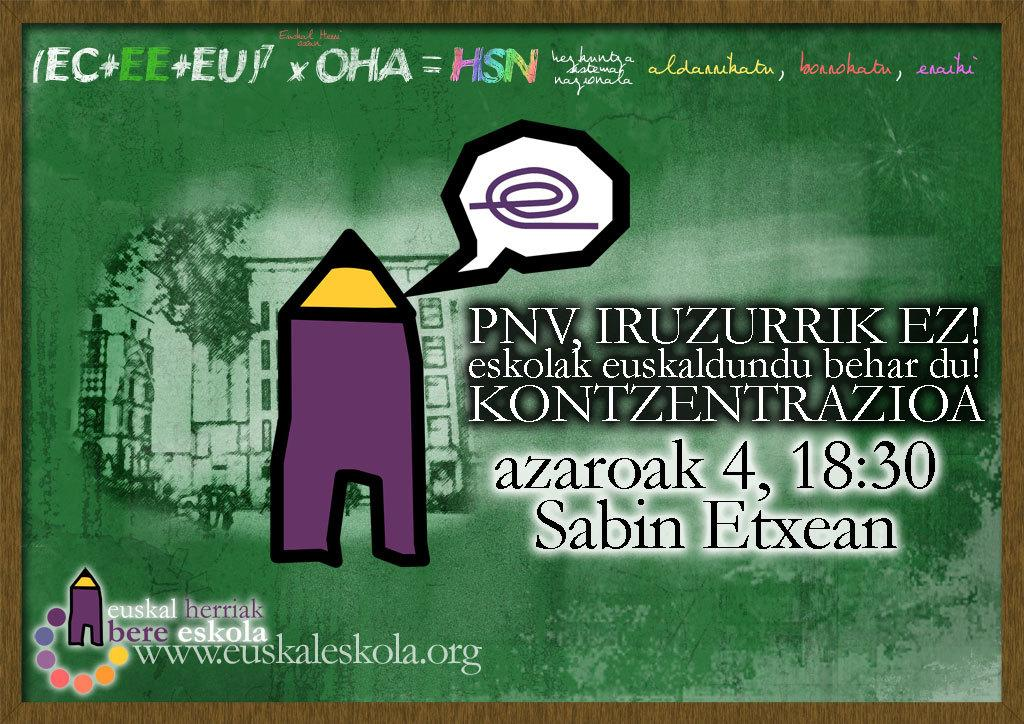What type of content is the image promoting? The image is an advertisement. Are there any recognizable symbols or brands in the image? Yes, there are logos in the image. What type of structure can be seen in the image? There is a building in the image. What other natural elements are present in the image? There is a tree in the image. What type of information is conveyed through the image? There is text in the image. What color is predominant in the background of the image? The background of the image is green. How many eggs are being used to create the wave in the image? There is no wave or eggs present in the image. 